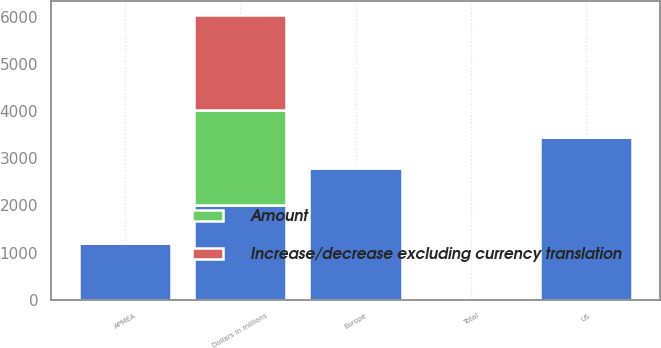Convert chart to OTSL. <chart><loc_0><loc_0><loc_500><loc_500><stacked_bar_chart><ecel><fcel>Dollars in millions<fcel>US<fcel>Europe<fcel>APMEA<fcel>Total<nl><fcel>nan<fcel>2010<fcel>3446<fcel>2797<fcel>1200<fcel>16.5<nl><fcel>Increase/decrease excluding currency translation<fcel>2010<fcel>7<fcel>8<fcel>21<fcel>9<nl><fcel>Amount<fcel>2010<fcel>7<fcel>12<fcel>11<fcel>9<nl></chart> 